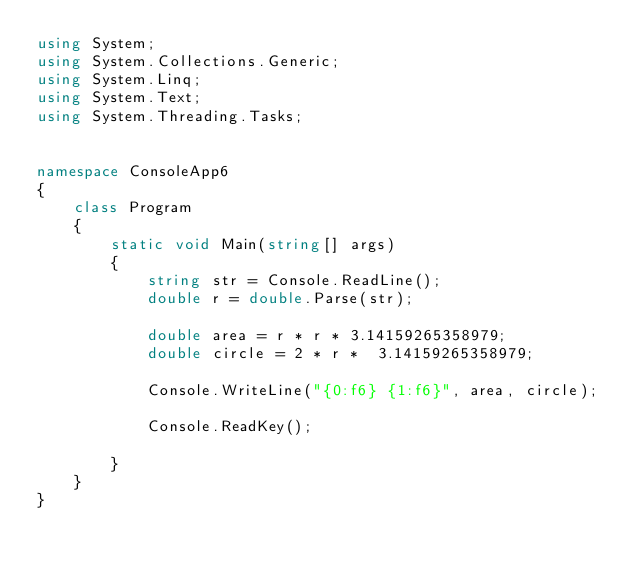Convert code to text. <code><loc_0><loc_0><loc_500><loc_500><_C#_>using System;
using System.Collections.Generic;
using System.Linq;
using System.Text;
using System.Threading.Tasks;


namespace ConsoleApp6
{
	class Program
	{
		static void Main(string[] args)
		{
			string str = Console.ReadLine();
			double r = double.Parse(str);

			double area = r * r * 3.14159265358979;
			double circle = 2 * r *  3.14159265358979;

			Console.WriteLine("{0:f6} {1:f6}", area, circle);

			Console.ReadKey();

		}
	}
}

</code> 